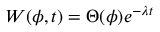<formula> <loc_0><loc_0><loc_500><loc_500>\begin{array} { r } { W ( \phi , t ) = \Theta ( \phi ) e ^ { - \lambda t } } \end{array}</formula> 